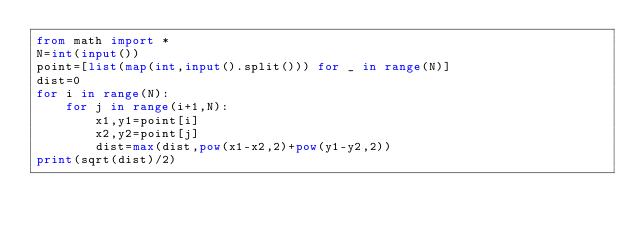Convert code to text. <code><loc_0><loc_0><loc_500><loc_500><_Python_>from math import *
N=int(input())
point=[list(map(int,input().split())) for _ in range(N)]
dist=0
for i in range(N):
    for j in range(i+1,N):
        x1,y1=point[i]
        x2,y2=point[j]
        dist=max(dist,pow(x1-x2,2)+pow(y1-y2,2))
print(sqrt(dist)/2)</code> 